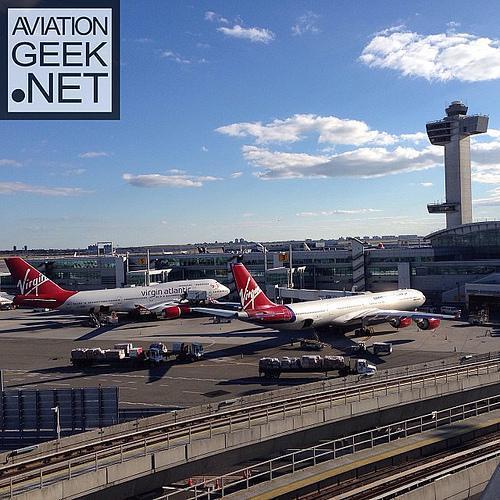How many airplanes are in the picture?
Give a very brief answer. 2. 